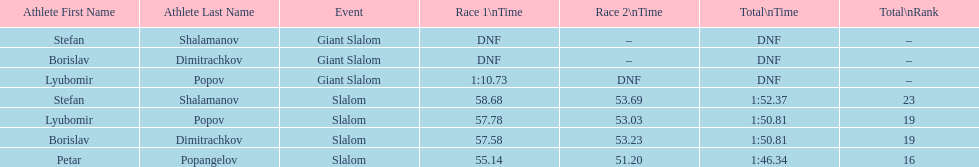What is the difference in time for petar popangelov in race 1and 2 3.94. 